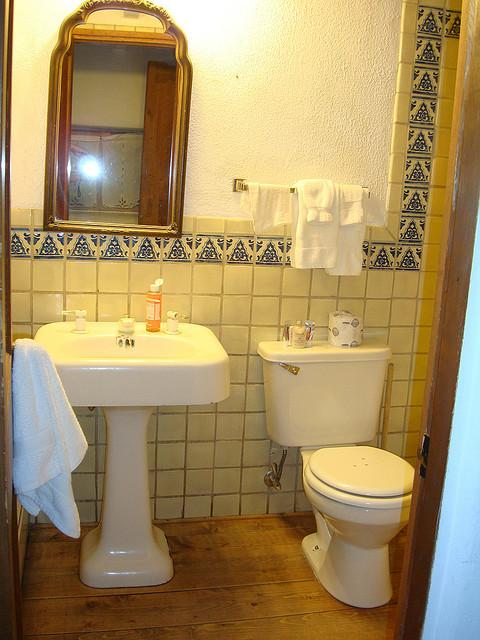Why do sanitary items comes in white color? cleanliness 